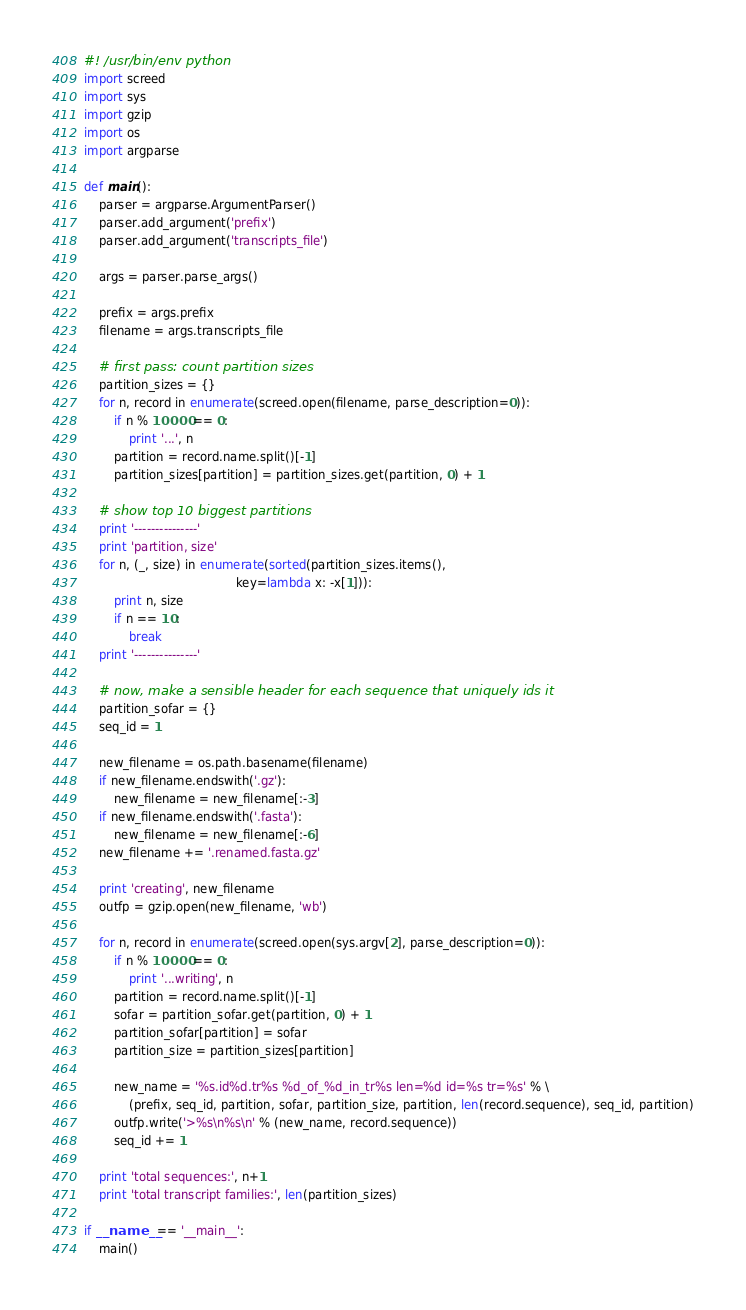<code> <loc_0><loc_0><loc_500><loc_500><_Python_>#! /usr/bin/env python
import screed
import sys
import gzip
import os
import argparse

def main():
    parser = argparse.ArgumentParser()
    parser.add_argument('prefix')
    parser.add_argument('transcripts_file')

    args = parser.parse_args()

    prefix = args.prefix
    filename = args.transcripts_file

    # first pass: count partition sizes
    partition_sizes = {}
    for n, record in enumerate(screed.open(filename, parse_description=0)):
        if n % 10000 == 0:
            print '...', n
        partition = record.name.split()[-1]
        partition_sizes[partition] = partition_sizes.get(partition, 0) + 1

    # show top 10 biggest partitions
    print '---------------'
    print 'partition, size'
    for n, (_, size) in enumerate(sorted(partition_sizes.items(),
                                         key=lambda x: -x[1])):
        print n, size
        if n == 10:
            break
    print '---------------'

    # now, make a sensible header for each sequence that uniquely ids it
    partition_sofar = {}
    seq_id = 1

    new_filename = os.path.basename(filename)
    if new_filename.endswith('.gz'):
        new_filename = new_filename[:-3]
    if new_filename.endswith('.fasta'):
        new_filename = new_filename[:-6]
    new_filename += '.renamed.fasta.gz'

    print 'creating', new_filename
    outfp = gzip.open(new_filename, 'wb')

    for n, record in enumerate(screed.open(sys.argv[2], parse_description=0)):
        if n % 10000 == 0:
            print '...writing', n
        partition = record.name.split()[-1]
        sofar = partition_sofar.get(partition, 0) + 1
        partition_sofar[partition] = sofar
        partition_size = partition_sizes[partition]

        new_name = '%s.id%d.tr%s %d_of_%d_in_tr%s len=%d id=%s tr=%s' % \
            (prefix, seq_id, partition, sofar, partition_size, partition, len(record.sequence), seq_id, partition)
        outfp.write('>%s\n%s\n' % (new_name, record.sequence))
        seq_id += 1

    print 'total sequences:', n+1
    print 'total transcript families:', len(partition_sizes)

if __name__ == '__main__':
    main()

</code> 